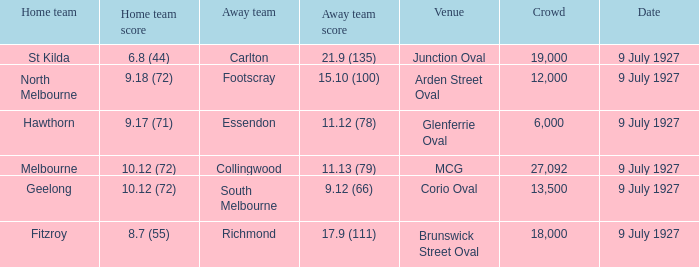Who was the away team playing the home team North Melbourne? Footscray. 